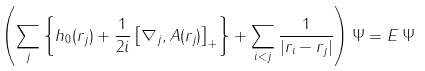Convert formula to latex. <formula><loc_0><loc_0><loc_500><loc_500>\left ( \sum _ { j } \left \{ h _ { 0 } ( { r } _ { j } ) + \frac { 1 } { 2 i } \left [ \nabla _ { j } , { A } ( { r } _ { j } ) \right ] _ { + } \right \} + \sum _ { i < j } \frac { 1 } { | { r } _ { i } - { r } _ { j } | } \right ) \Psi = E \, \Psi</formula> 